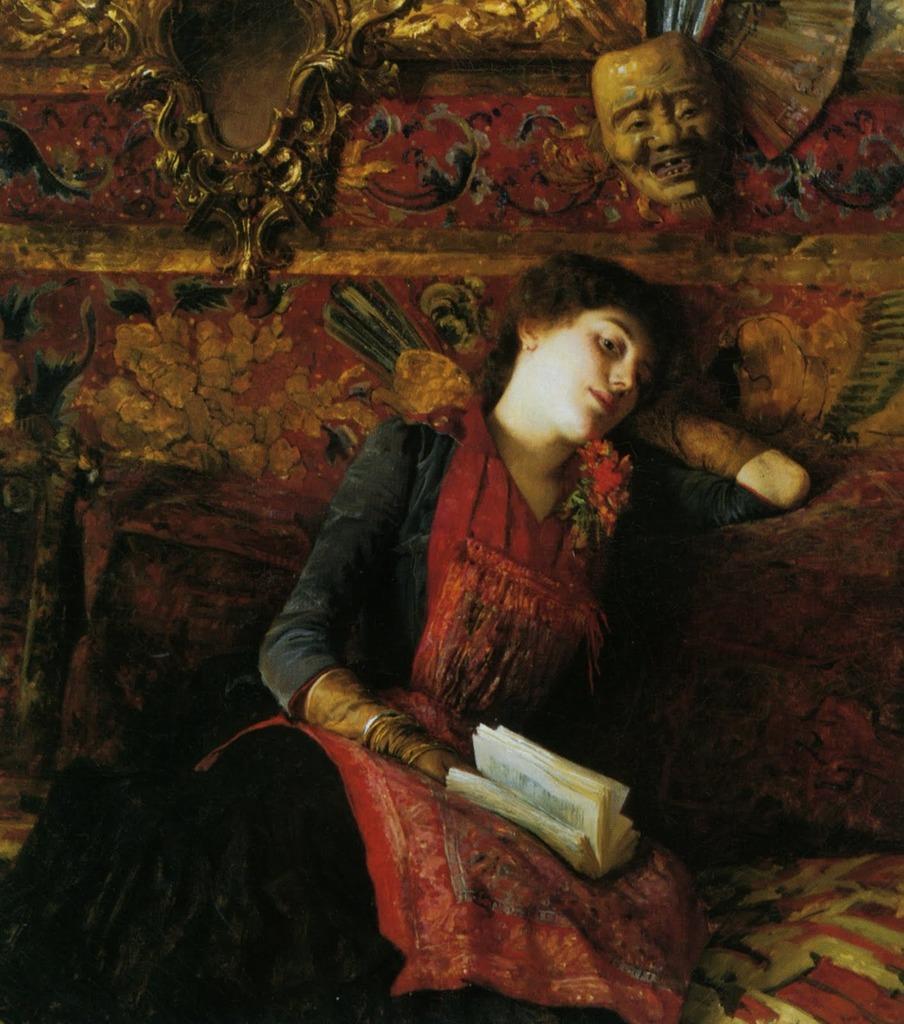Can you describe this image briefly? As we can see in the image. The woman is sitting on the bed and she is holding a book in her hand and she is wearing a red color dress. 